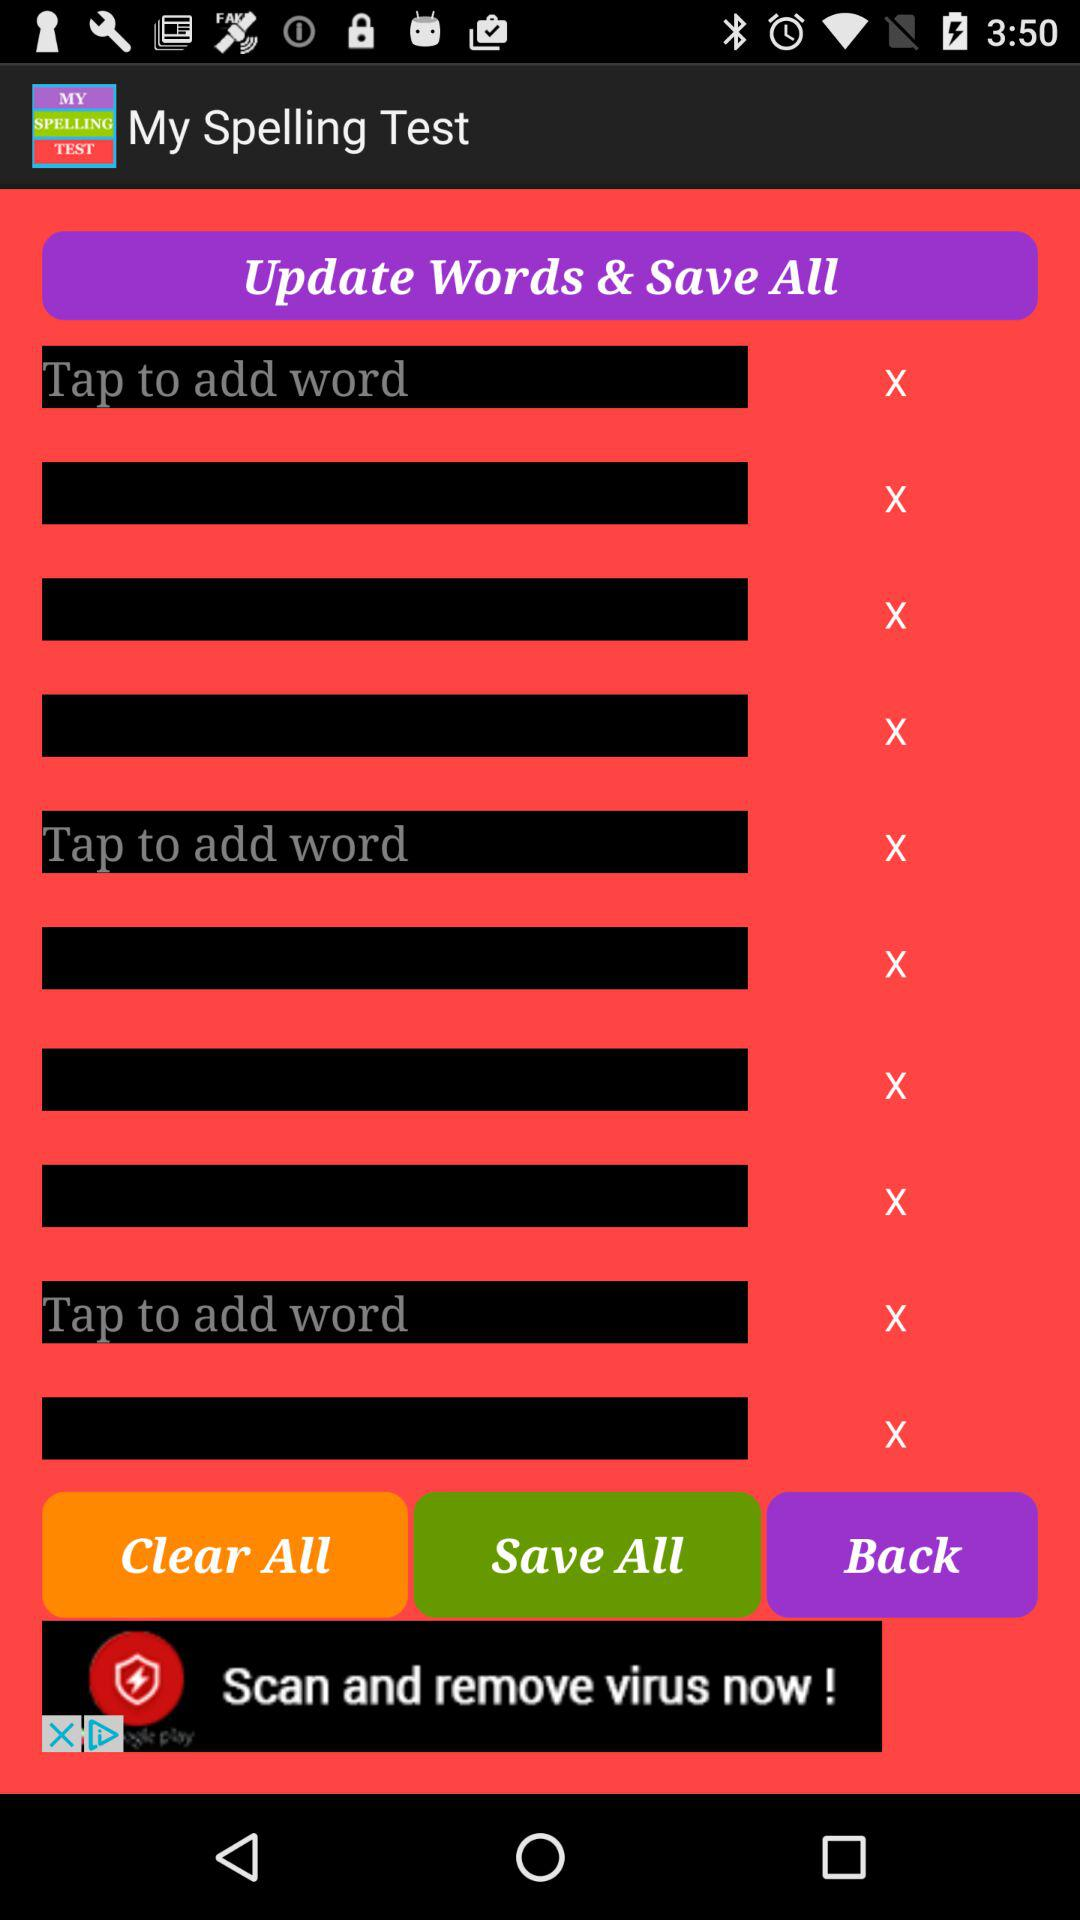What is the application name? The application name is "My Spelling Test". 